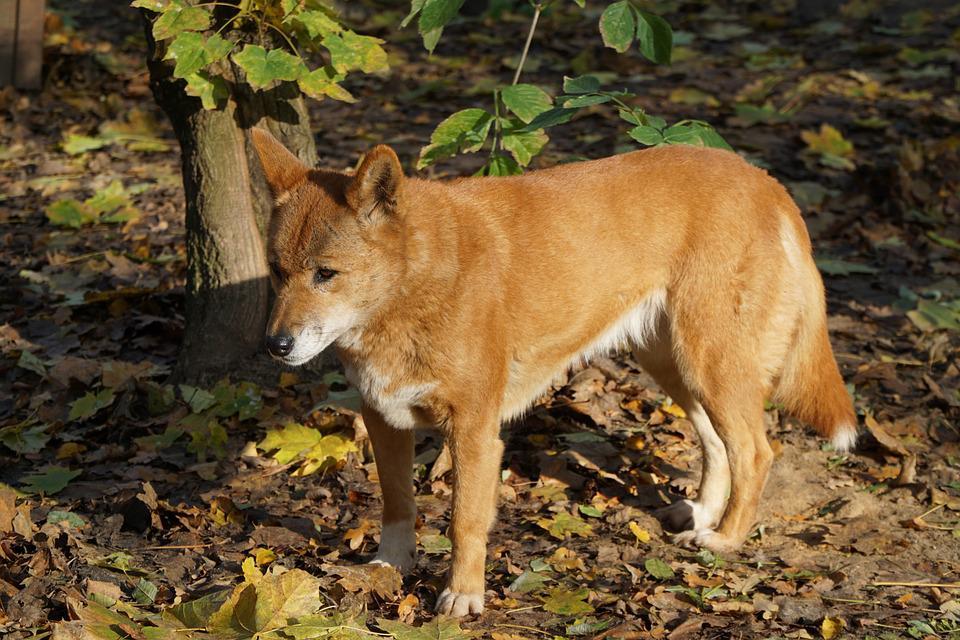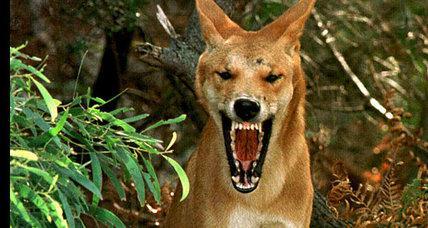The first image is the image on the left, the second image is the image on the right. For the images displayed, is the sentence "There are two dogs total on both images." factually correct? Answer yes or no. Yes. 